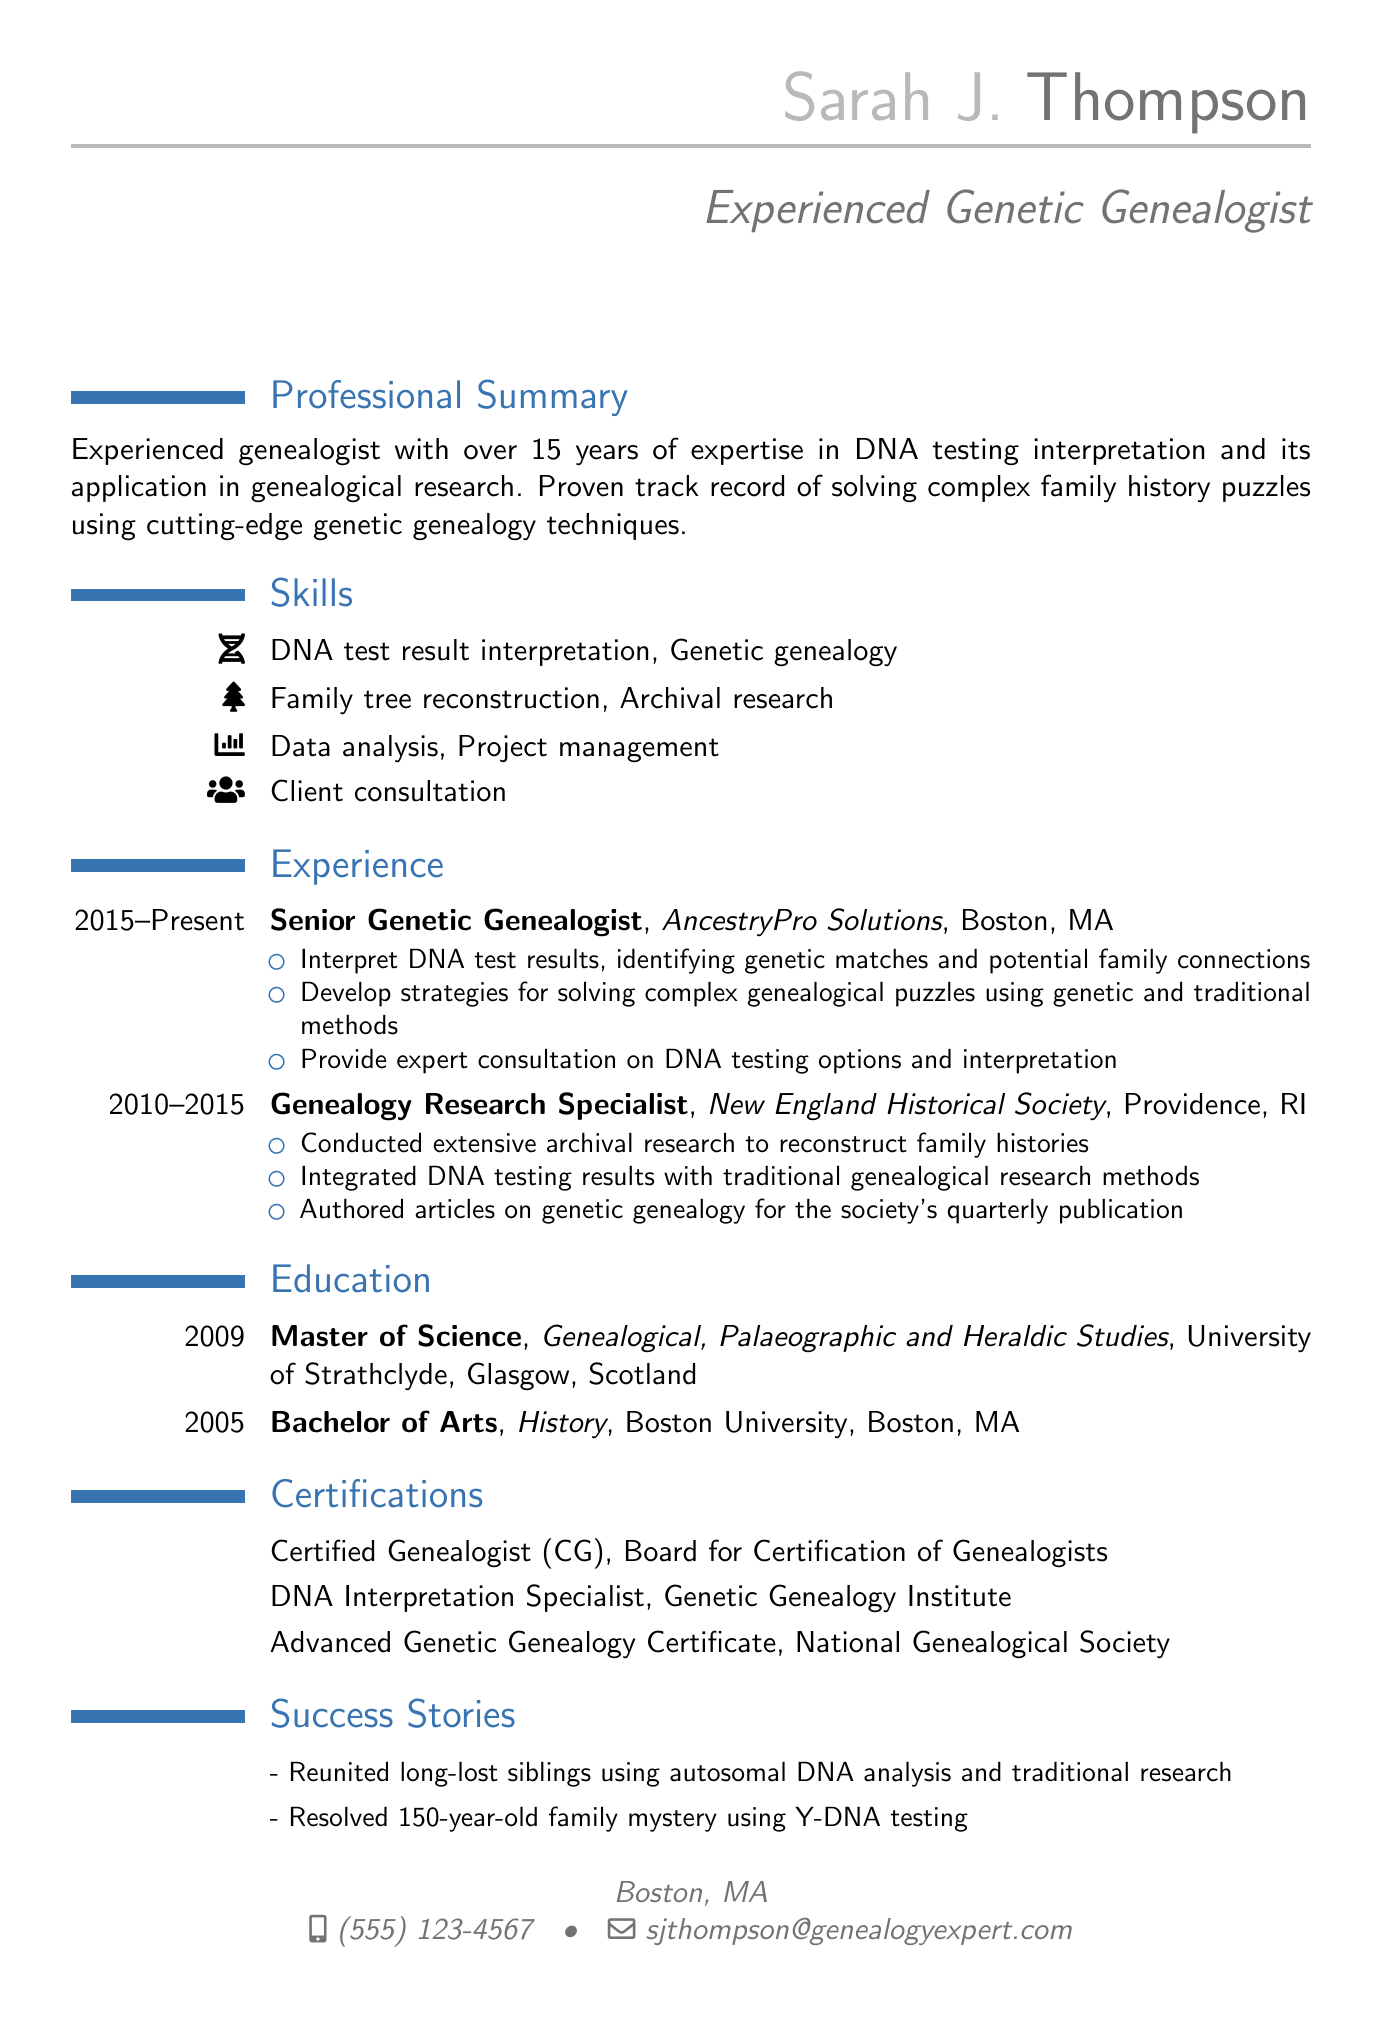What is Sarah J. Thompson's email address? The email address is listed under personal information.
Answer: sjthompson@genealogyexpert.com How many years of experience does Sarah have in genealogical research? The professional summary states her experience as "over 15 years."
Answer: over 15 years What is the highest degree Sarah earned? The highest degree can be found in the education section.
Answer: Master of Science Which certification is awarded by the Board for Certification of Genealogists? This certification is mentioned in the certifications section.
Answer: Certified Genealogist (CG) What significant result did Sarah achieve in a success story? A success story indicates her ability to solve a long-term family mystery.
Answer: Resolved a 150-year-old family mystery Which organization is Sarah a member of that focuses on genealogy? The professional memberships provide information on organizations she is part of.
Answer: National Genealogical Society What role has Sarah held since 2015? This information is provided in the experience section of the resume.
Answer: Senior Genetic Genealogist How many success stories are listed in the document? The count of success stories can be determined by reviewing that section.
Answer: Three 